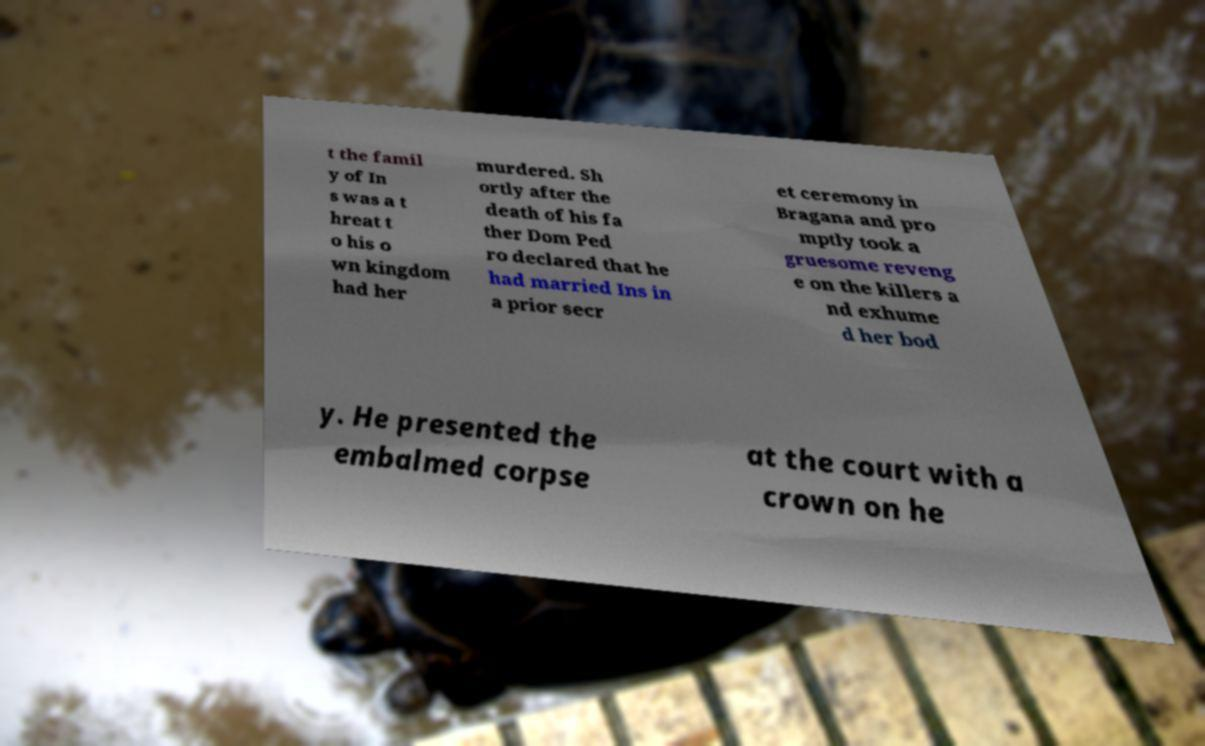Could you extract and type out the text from this image? t the famil y of In s was a t hreat t o his o wn kingdom had her murdered. Sh ortly after the death of his fa ther Dom Ped ro declared that he had married Ins in a prior secr et ceremony in Bragana and pro mptly took a gruesome reveng e on the killers a nd exhume d her bod y. He presented the embalmed corpse at the court with a crown on he 